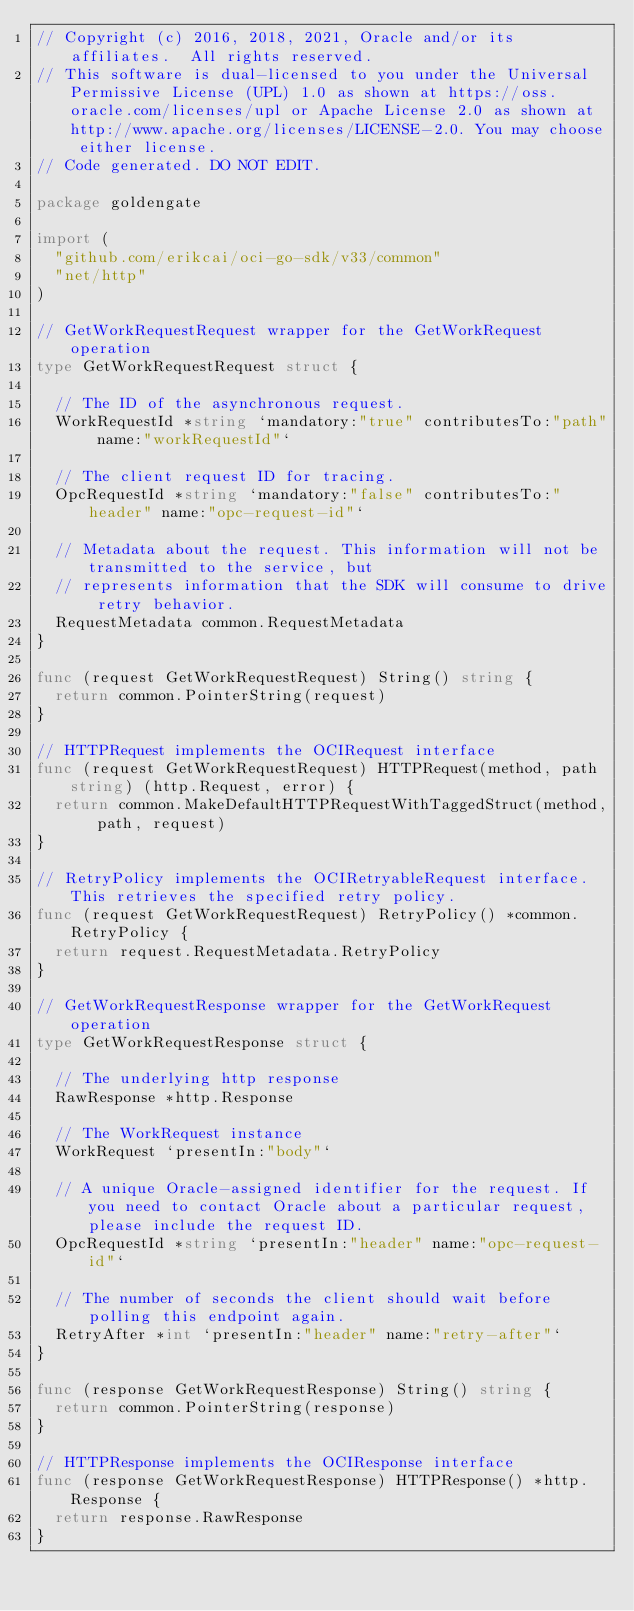<code> <loc_0><loc_0><loc_500><loc_500><_Go_>// Copyright (c) 2016, 2018, 2021, Oracle and/or its affiliates.  All rights reserved.
// This software is dual-licensed to you under the Universal Permissive License (UPL) 1.0 as shown at https://oss.oracle.com/licenses/upl or Apache License 2.0 as shown at http://www.apache.org/licenses/LICENSE-2.0. You may choose either license.
// Code generated. DO NOT EDIT.

package goldengate

import (
	"github.com/erikcai/oci-go-sdk/v33/common"
	"net/http"
)

// GetWorkRequestRequest wrapper for the GetWorkRequest operation
type GetWorkRequestRequest struct {

	// The ID of the asynchronous request.
	WorkRequestId *string `mandatory:"true" contributesTo:"path" name:"workRequestId"`

	// The client request ID for tracing.
	OpcRequestId *string `mandatory:"false" contributesTo:"header" name:"opc-request-id"`

	// Metadata about the request. This information will not be transmitted to the service, but
	// represents information that the SDK will consume to drive retry behavior.
	RequestMetadata common.RequestMetadata
}

func (request GetWorkRequestRequest) String() string {
	return common.PointerString(request)
}

// HTTPRequest implements the OCIRequest interface
func (request GetWorkRequestRequest) HTTPRequest(method, path string) (http.Request, error) {
	return common.MakeDefaultHTTPRequestWithTaggedStruct(method, path, request)
}

// RetryPolicy implements the OCIRetryableRequest interface. This retrieves the specified retry policy.
func (request GetWorkRequestRequest) RetryPolicy() *common.RetryPolicy {
	return request.RequestMetadata.RetryPolicy
}

// GetWorkRequestResponse wrapper for the GetWorkRequest operation
type GetWorkRequestResponse struct {

	// The underlying http response
	RawResponse *http.Response

	// The WorkRequest instance
	WorkRequest `presentIn:"body"`

	// A unique Oracle-assigned identifier for the request. If you need to contact Oracle about a particular request, please include the request ID.
	OpcRequestId *string `presentIn:"header" name:"opc-request-id"`

	// The number of seconds the client should wait before polling this endpoint again.
	RetryAfter *int `presentIn:"header" name:"retry-after"`
}

func (response GetWorkRequestResponse) String() string {
	return common.PointerString(response)
}

// HTTPResponse implements the OCIResponse interface
func (response GetWorkRequestResponse) HTTPResponse() *http.Response {
	return response.RawResponse
}
</code> 